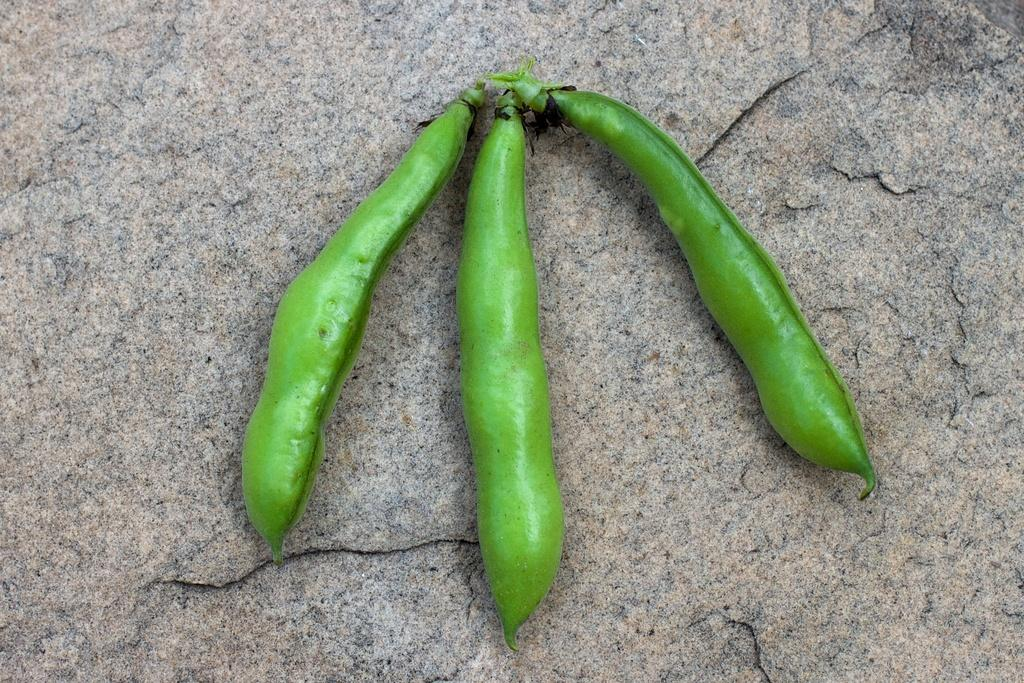What are the main subjects in the image? There are three green peas in the image. Where are the green peas located? The green peas are placed on a rock platform. What type of bait is being used for fishing in the image? There is no fishing or bait present in the image; it features three green peas on a rock platform. What is the angle of the slope in the image? There is no slope present in the image; it features three green peas on a rock platform. 